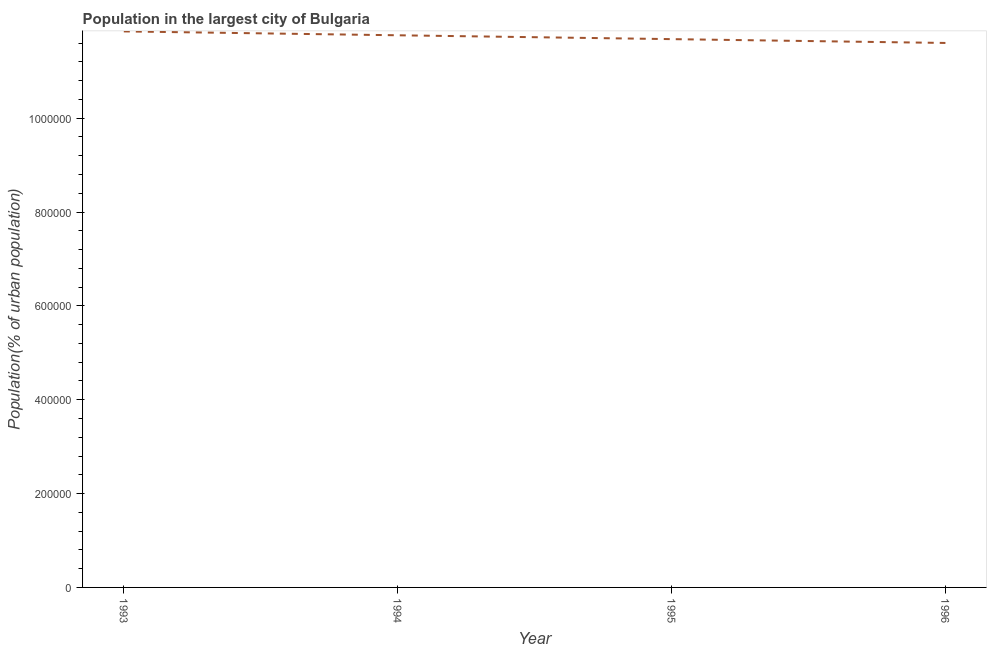What is the population in largest city in 1993?
Provide a short and direct response. 1.18e+06. Across all years, what is the maximum population in largest city?
Make the answer very short. 1.18e+06. Across all years, what is the minimum population in largest city?
Make the answer very short. 1.16e+06. In which year was the population in largest city maximum?
Give a very brief answer. 1993. What is the sum of the population in largest city?
Offer a very short reply. 4.69e+06. What is the difference between the population in largest city in 1993 and 1996?
Offer a terse response. 2.46e+04. What is the average population in largest city per year?
Offer a terse response. 1.17e+06. What is the median population in largest city?
Offer a very short reply. 1.17e+06. In how many years, is the population in largest city greater than 680000 %?
Your answer should be very brief. 4. Do a majority of the years between 1995 and 1996 (inclusive) have population in largest city greater than 880000 %?
Your answer should be compact. Yes. What is the ratio of the population in largest city in 1993 to that in 1995?
Your answer should be compact. 1.01. Is the population in largest city in 1995 less than that in 1996?
Keep it short and to the point. No. What is the difference between the highest and the second highest population in largest city?
Your answer should be compact. 8261. What is the difference between the highest and the lowest population in largest city?
Keep it short and to the point. 2.46e+04. In how many years, is the population in largest city greater than the average population in largest city taken over all years?
Ensure brevity in your answer.  2. Does the population in largest city monotonically increase over the years?
Ensure brevity in your answer.  No. How many lines are there?
Give a very brief answer. 1. What is the difference between two consecutive major ticks on the Y-axis?
Provide a succinct answer. 2.00e+05. Are the values on the major ticks of Y-axis written in scientific E-notation?
Ensure brevity in your answer.  No. Does the graph contain any zero values?
Ensure brevity in your answer.  No. Does the graph contain grids?
Your answer should be very brief. No. What is the title of the graph?
Your answer should be compact. Population in the largest city of Bulgaria. What is the label or title of the X-axis?
Provide a short and direct response. Year. What is the label or title of the Y-axis?
Ensure brevity in your answer.  Population(% of urban population). What is the Population(% of urban population) of 1993?
Offer a very short reply. 1.18e+06. What is the Population(% of urban population) in 1994?
Keep it short and to the point. 1.18e+06. What is the Population(% of urban population) of 1995?
Ensure brevity in your answer.  1.17e+06. What is the Population(% of urban population) of 1996?
Your response must be concise. 1.16e+06. What is the difference between the Population(% of urban population) in 1993 and 1994?
Ensure brevity in your answer.  8261. What is the difference between the Population(% of urban population) in 1993 and 1995?
Make the answer very short. 1.65e+04. What is the difference between the Population(% of urban population) in 1993 and 1996?
Your answer should be compact. 2.46e+04. What is the difference between the Population(% of urban population) in 1994 and 1995?
Provide a succinct answer. 8203. What is the difference between the Population(% of urban population) in 1994 and 1996?
Keep it short and to the point. 1.64e+04. What is the difference between the Population(% of urban population) in 1995 and 1996?
Provide a short and direct response. 8158. What is the ratio of the Population(% of urban population) in 1993 to that in 1994?
Provide a short and direct response. 1.01. What is the ratio of the Population(% of urban population) in 1993 to that in 1995?
Your response must be concise. 1.01. What is the ratio of the Population(% of urban population) in 1995 to that in 1996?
Give a very brief answer. 1.01. 